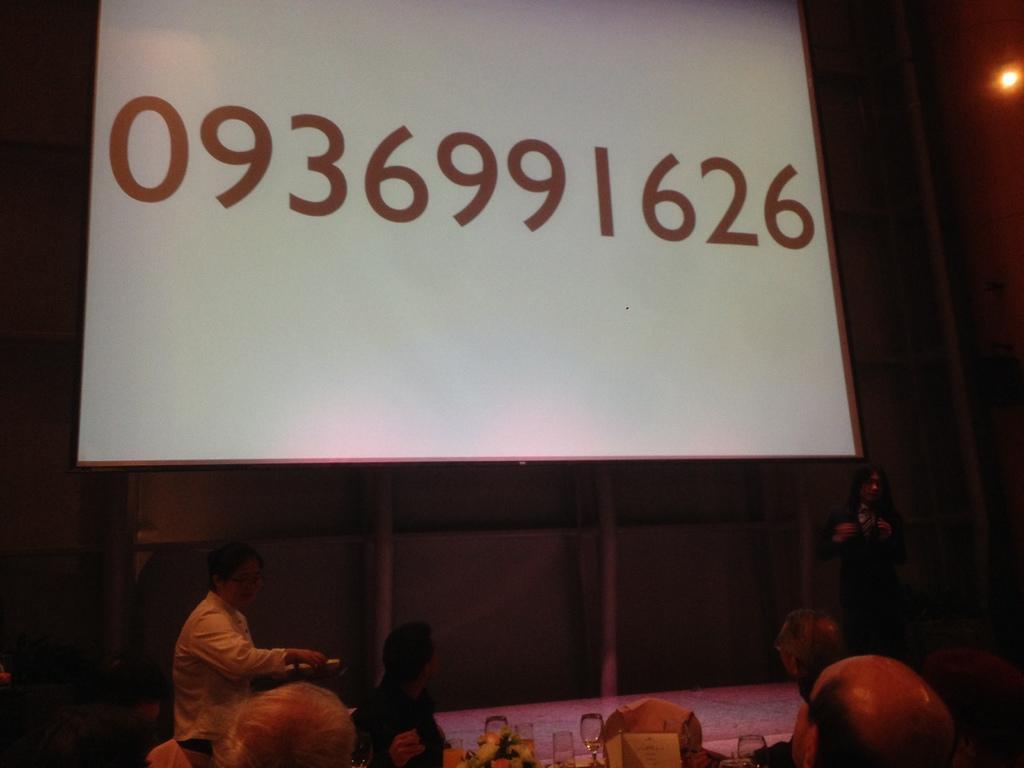Could you give a brief overview of what you see in this image? In this image in front there are people. There is a table. On top of it there are glasses and a few other objects. In the background of the image there is a board with numbers on it. On the right side of the image there is a light. 